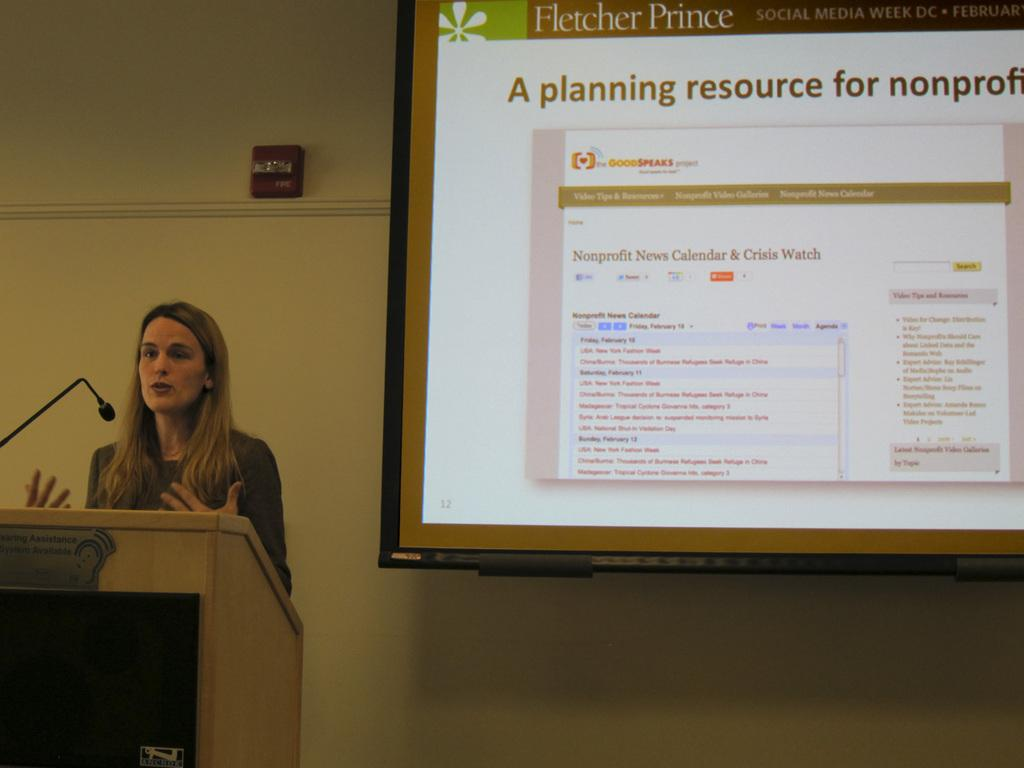What is the position of the woman in the image? The woman is on the left side of the image. What is the woman doing in the image? The woman is talking in the image. What object is in front of the woman? There is a podium in front of the woman. What is on the podium? There is a microphone on the podium. What can be seen on the right side of the image? There is a screen on the right side of the image, mounted on the wall. What day is the woman celebrating in the image? There is no indication of a specific day being celebrated in the image. Is the woman a spy in the image? There is no information in the image to suggest that the woman is a spy. 